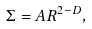<formula> <loc_0><loc_0><loc_500><loc_500>\Sigma = A R ^ { 2 - D } ,</formula> 